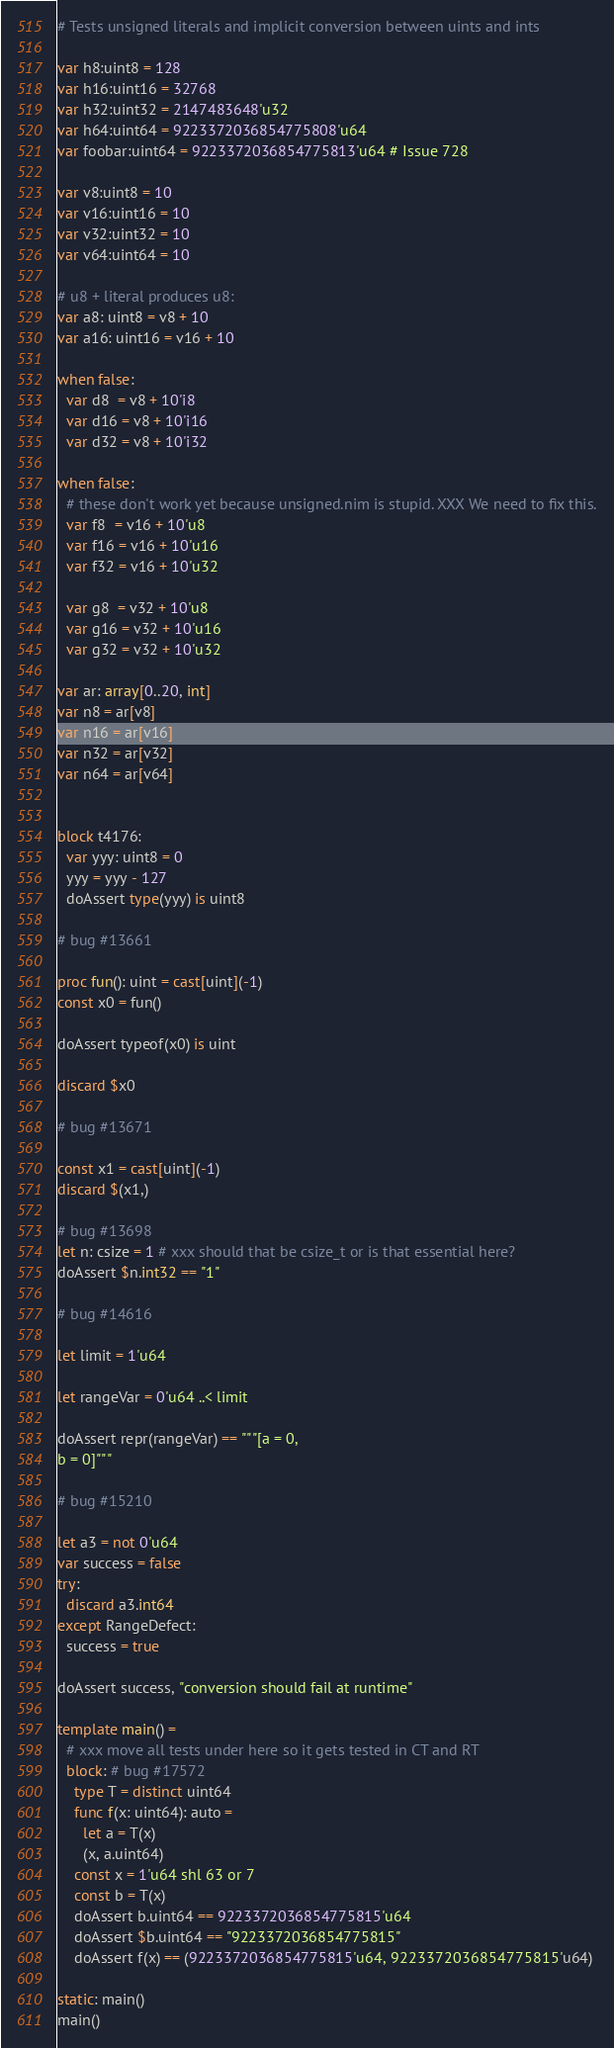<code> <loc_0><loc_0><loc_500><loc_500><_Nim_># Tests unsigned literals and implicit conversion between uints and ints

var h8:uint8 = 128
var h16:uint16 = 32768
var h32:uint32 = 2147483648'u32
var h64:uint64 = 9223372036854775808'u64
var foobar:uint64 = 9223372036854775813'u64 # Issue 728

var v8:uint8 = 10
var v16:uint16 = 10
var v32:uint32 = 10
var v64:uint64 = 10

# u8 + literal produces u8:
var a8: uint8 = v8 + 10
var a16: uint16 = v16 + 10

when false:
  var d8  = v8 + 10'i8
  var d16 = v8 + 10'i16
  var d32 = v8 + 10'i32

when false:
  # these don't work yet because unsigned.nim is stupid. XXX We need to fix this.
  var f8  = v16 + 10'u8
  var f16 = v16 + 10'u16
  var f32 = v16 + 10'u32

  var g8  = v32 + 10'u8
  var g16 = v32 + 10'u16
  var g32 = v32 + 10'u32

var ar: array[0..20, int]
var n8 = ar[v8]
var n16 = ar[v16]
var n32 = ar[v32]
var n64 = ar[v64]


block t4176:
  var yyy: uint8 = 0
  yyy = yyy - 127
  doAssert type(yyy) is uint8

# bug #13661

proc fun(): uint = cast[uint](-1)
const x0 = fun()

doAssert typeof(x0) is uint

discard $x0

# bug #13671

const x1 = cast[uint](-1)
discard $(x1,)

# bug #13698
let n: csize = 1 # xxx should that be csize_t or is that essential here?
doAssert $n.int32 == "1"

# bug #14616

let limit = 1'u64

let rangeVar = 0'u64 ..< limit

doAssert repr(rangeVar) == """[a = 0,
b = 0]"""

# bug #15210

let a3 = not 0'u64
var success = false
try:
  discard a3.int64
except RangeDefect:
  success = true

doAssert success, "conversion should fail at runtime"

template main() =
  # xxx move all tests under here so it gets tested in CT and RT
  block: # bug #17572
    type T = distinct uint64
    func f(x: uint64): auto =
      let a = T(x)
      (x, a.uint64)
    const x = 1'u64 shl 63 or 7
    const b = T(x)
    doAssert b.uint64 == 9223372036854775815'u64
    doAssert $b.uint64 == "9223372036854775815"
    doAssert f(x) == (9223372036854775815'u64, 9223372036854775815'u64)

static: main()
main()
</code> 